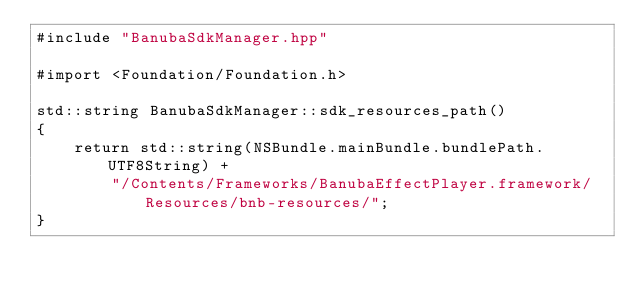<code> <loc_0><loc_0><loc_500><loc_500><_ObjectiveC_>#include "BanubaSdkManager.hpp"

#import <Foundation/Foundation.h>

std::string BanubaSdkManager::sdk_resources_path() 
{
    return std::string(NSBundle.mainBundle.bundlePath.UTF8String) +
        "/Contents/Frameworks/BanubaEffectPlayer.framework/Resources/bnb-resources/";
}
</code> 